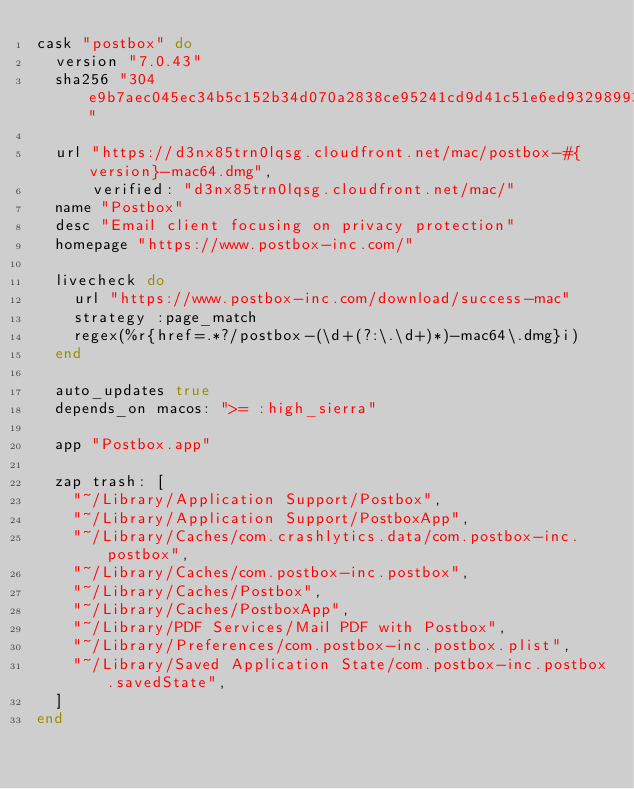<code> <loc_0><loc_0><loc_500><loc_500><_Ruby_>cask "postbox" do
  version "7.0.43"
  sha256 "304e9b7aec045ec34b5c152b34d070a2838ce95241cd9d41c51e6ed93298993c"

  url "https://d3nx85trn0lqsg.cloudfront.net/mac/postbox-#{version}-mac64.dmg",
      verified: "d3nx85trn0lqsg.cloudfront.net/mac/"
  name "Postbox"
  desc "Email client focusing on privacy protection"
  homepage "https://www.postbox-inc.com/"

  livecheck do
    url "https://www.postbox-inc.com/download/success-mac"
    strategy :page_match
    regex(%r{href=.*?/postbox-(\d+(?:\.\d+)*)-mac64\.dmg}i)
  end

  auto_updates true
  depends_on macos: ">= :high_sierra"

  app "Postbox.app"

  zap trash: [
    "~/Library/Application Support/Postbox",
    "~/Library/Application Support/PostboxApp",
    "~/Library/Caches/com.crashlytics.data/com.postbox-inc.postbox",
    "~/Library/Caches/com.postbox-inc.postbox",
    "~/Library/Caches/Postbox",
    "~/Library/Caches/PostboxApp",
    "~/Library/PDF Services/Mail PDF with Postbox",
    "~/Library/Preferences/com.postbox-inc.postbox.plist",
    "~/Library/Saved Application State/com.postbox-inc.postbox.savedState",
  ]
end
</code> 